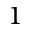Convert formula to latex. <formula><loc_0><loc_0><loc_500><loc_500>_ { 1 }</formula> 